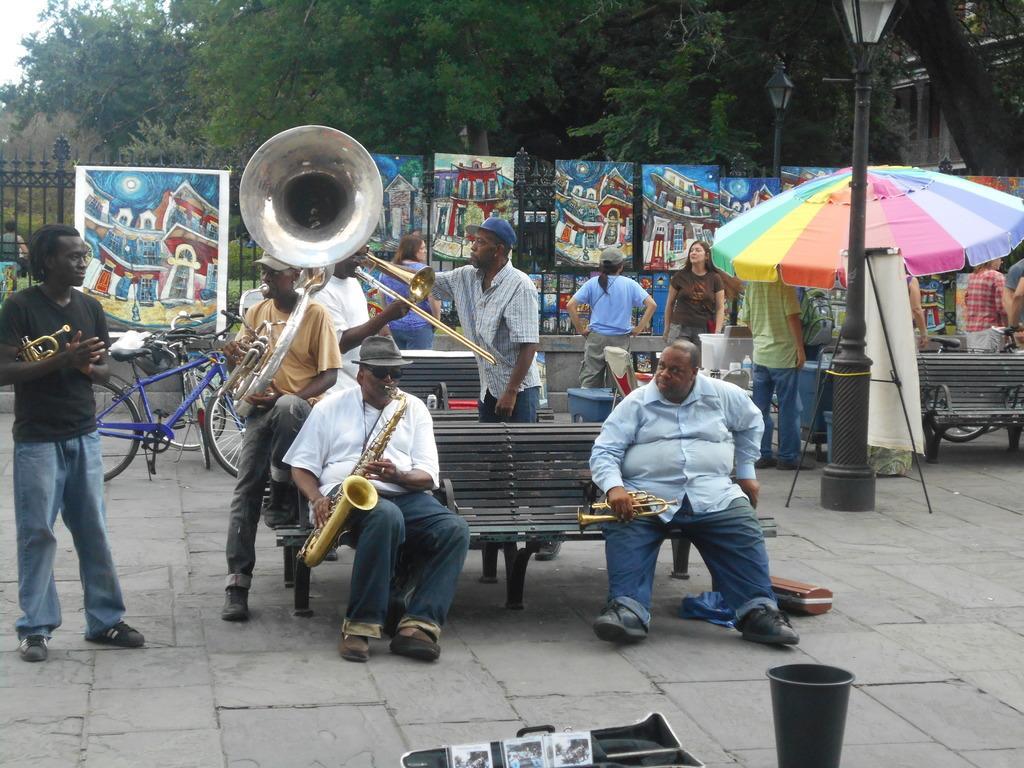Describe this image in one or two sentences. In this image I can see people where few are sitting and rest all are standing. I can see most of them are holding musical instruments. In the background I can see number of paintings, few bicycles, an umbrella, few benches, few poles, few street lights and number of trees. 